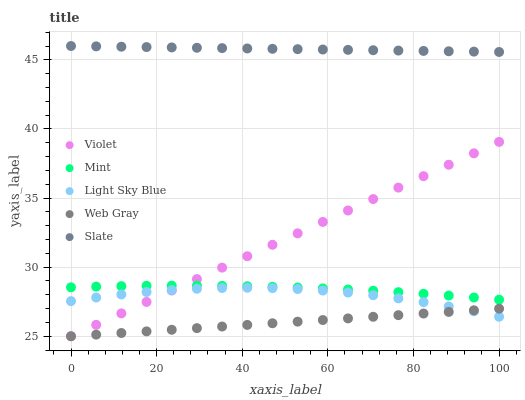Does Web Gray have the minimum area under the curve?
Answer yes or no. Yes. Does Slate have the maximum area under the curve?
Answer yes or no. Yes. Does Light Sky Blue have the minimum area under the curve?
Answer yes or no. No. Does Light Sky Blue have the maximum area under the curve?
Answer yes or no. No. Is Web Gray the smoothest?
Answer yes or no. Yes. Is Light Sky Blue the roughest?
Answer yes or no. Yes. Is Slate the smoothest?
Answer yes or no. No. Is Slate the roughest?
Answer yes or no. No. Does Web Gray have the lowest value?
Answer yes or no. Yes. Does Light Sky Blue have the lowest value?
Answer yes or no. No. Does Slate have the highest value?
Answer yes or no. Yes. Does Light Sky Blue have the highest value?
Answer yes or no. No. Is Light Sky Blue less than Mint?
Answer yes or no. Yes. Is Mint greater than Web Gray?
Answer yes or no. Yes. Does Mint intersect Violet?
Answer yes or no. Yes. Is Mint less than Violet?
Answer yes or no. No. Is Mint greater than Violet?
Answer yes or no. No. Does Light Sky Blue intersect Mint?
Answer yes or no. No. 